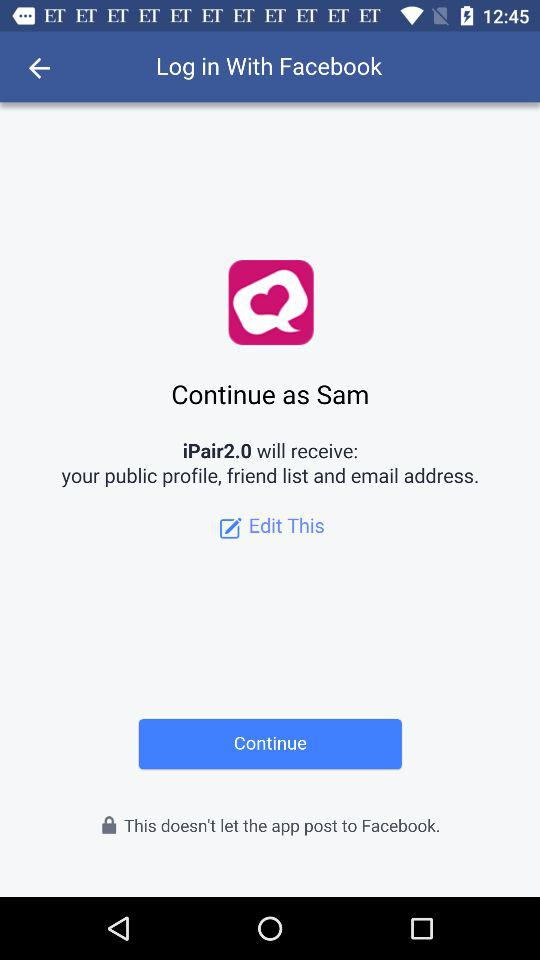What application is used to log in? The used application is "Facebook". 